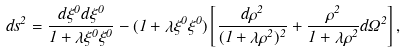Convert formula to latex. <formula><loc_0><loc_0><loc_500><loc_500>d s ^ { 2 } = \frac { d \xi ^ { 0 } d \xi ^ { 0 } } { 1 + \lambda \xi ^ { 0 } \xi ^ { 0 } } - ( 1 + \lambda \xi ^ { 0 } \xi ^ { 0 } ) \left [ \frac { d \rho ^ { 2 } } { ( 1 + \lambda \rho ^ { 2 } ) ^ { 2 } } + \frac { \rho ^ { 2 } } { 1 + \lambda \rho ^ { 2 } } d \Omega ^ { 2 } \right ] ,</formula> 